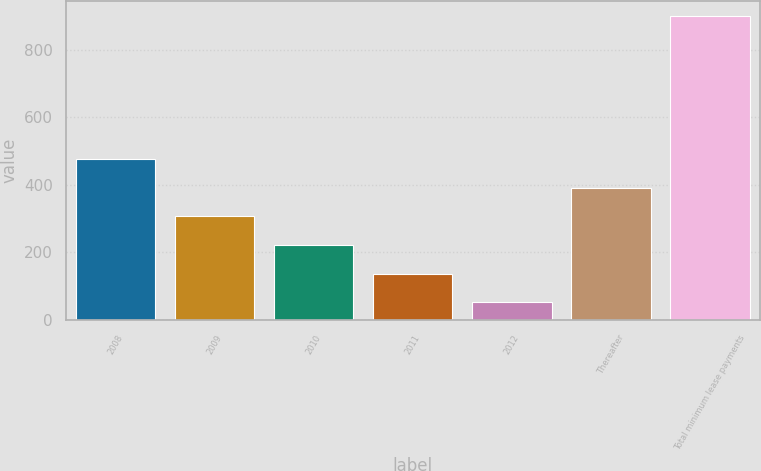<chart> <loc_0><loc_0><loc_500><loc_500><bar_chart><fcel>2008<fcel>2009<fcel>2010<fcel>2011<fcel>2012<fcel>Thereafter<fcel>Total minimum lease payments<nl><fcel>476.5<fcel>307.1<fcel>222.4<fcel>137.7<fcel>53<fcel>391.8<fcel>900<nl></chart> 